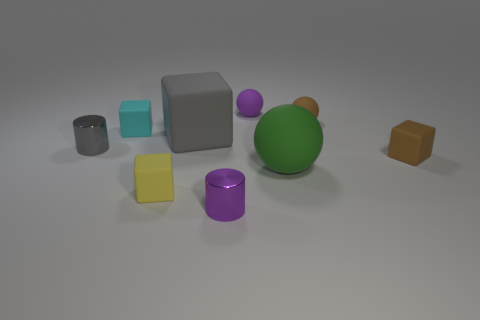What is the size of the metal object behind the small yellow block?
Keep it short and to the point. Small. There is a block that is to the right of the big rubber sphere; how many large green objects are in front of it?
Offer a very short reply. 1. How many other objects are there of the same size as the green rubber thing?
Make the answer very short. 1. Is the large rubber ball the same color as the large matte cube?
Your answer should be very brief. No. There is a purple object that is in front of the tiny yellow rubber object; is it the same shape as the green thing?
Your response must be concise. No. What number of tiny things are behind the tiny yellow cube and in front of the small brown ball?
Offer a very short reply. 3. What is the cyan object made of?
Make the answer very short. Rubber. Are there any other things that are the same color as the big rubber cube?
Offer a terse response. Yes. Do the tiny yellow thing and the gray cylinder have the same material?
Provide a short and direct response. No. What number of large blocks are to the right of the tiny brown thing that is in front of the big thing on the left side of the purple rubber sphere?
Give a very brief answer. 0. 